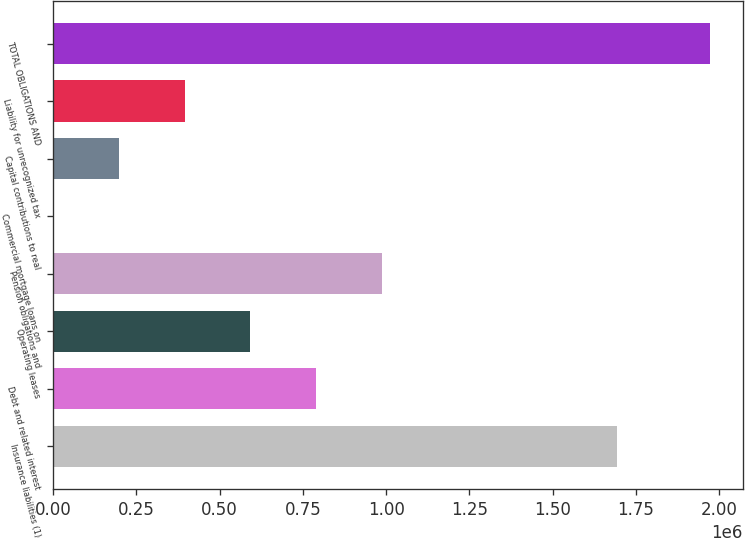Convert chart. <chart><loc_0><loc_0><loc_500><loc_500><bar_chart><fcel>Insurance liabilities (1)<fcel>Debt and related interest<fcel>Operating leases<fcel>Pension obligations and<fcel>Commercial mortgage loans on<fcel>Capital contributions to real<fcel>Liability for unrecognized tax<fcel>TOTAL OBLIGATIONS AND<nl><fcel>1.69432e+06<fcel>789059<fcel>591795<fcel>986324<fcel>2.03<fcel>197266<fcel>394531<fcel>1.97264e+06<nl></chart> 